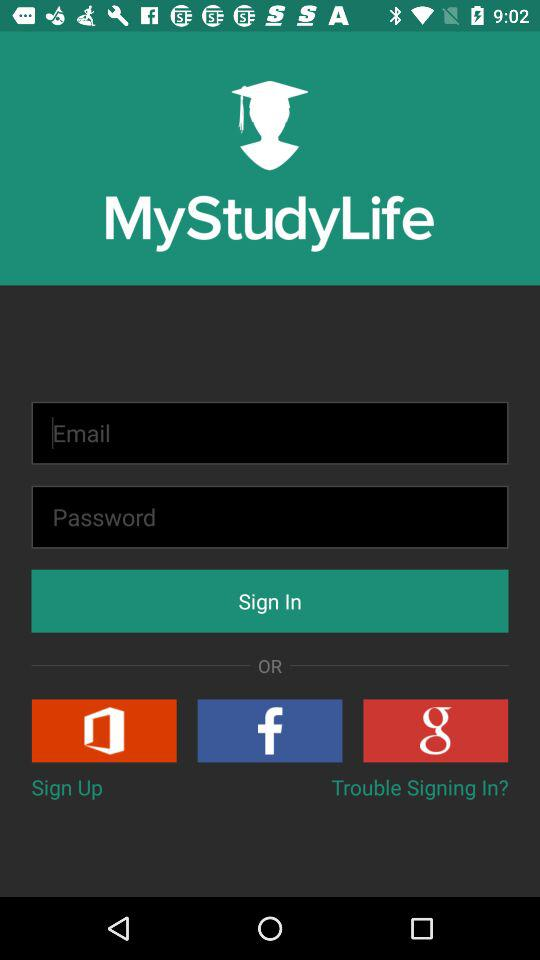What is the application name? The application name "MyStudyLife". 